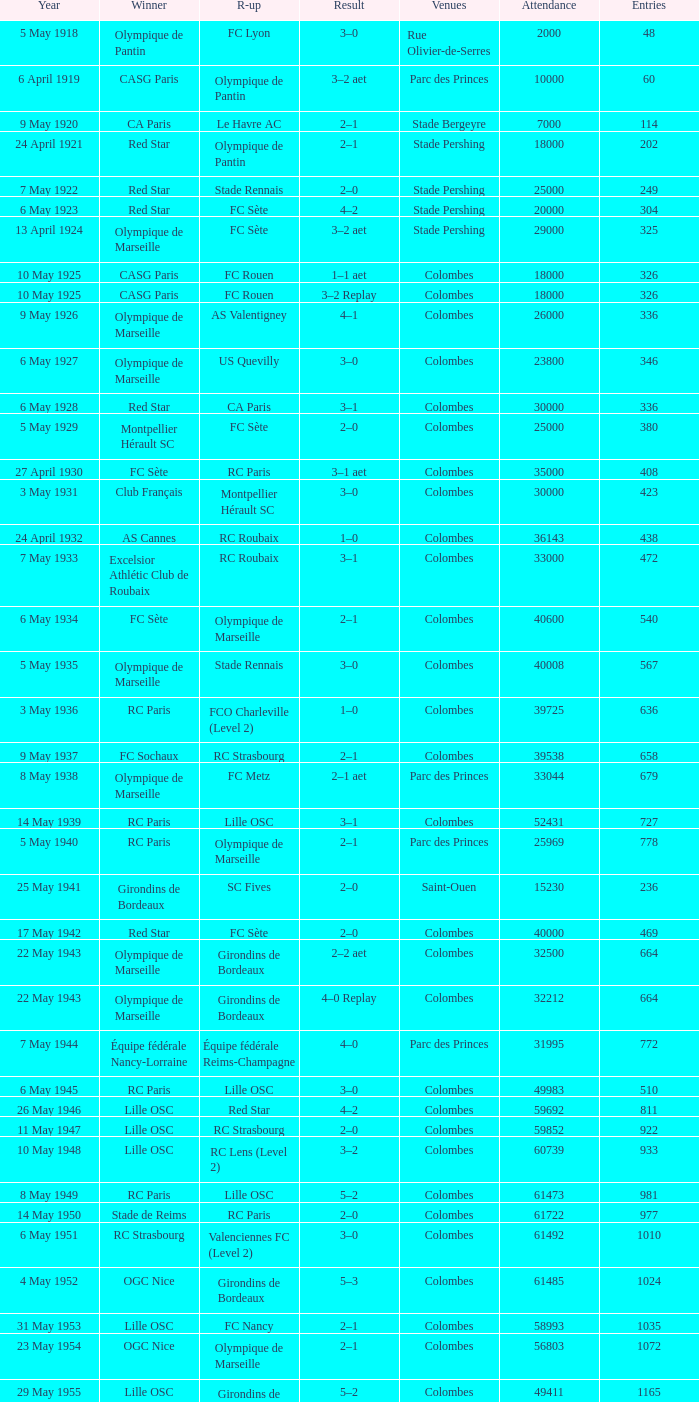How many games had red star as the runner up? 1.0. 